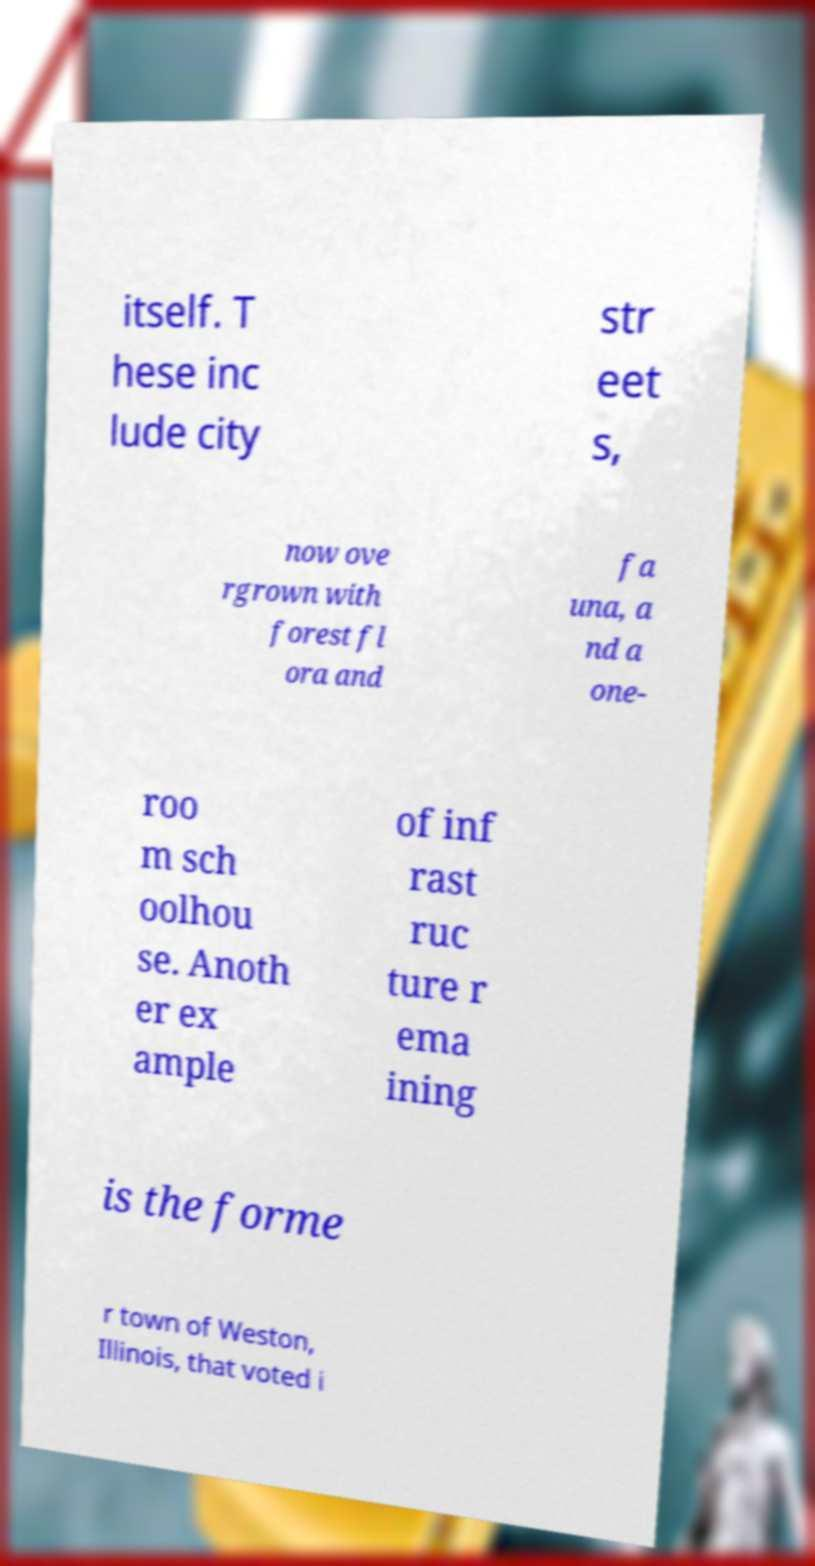For documentation purposes, I need the text within this image transcribed. Could you provide that? itself. T hese inc lude city str eet s, now ove rgrown with forest fl ora and fa una, a nd a one- roo m sch oolhou se. Anoth er ex ample of inf rast ruc ture r ema ining is the forme r town of Weston, Illinois, that voted i 